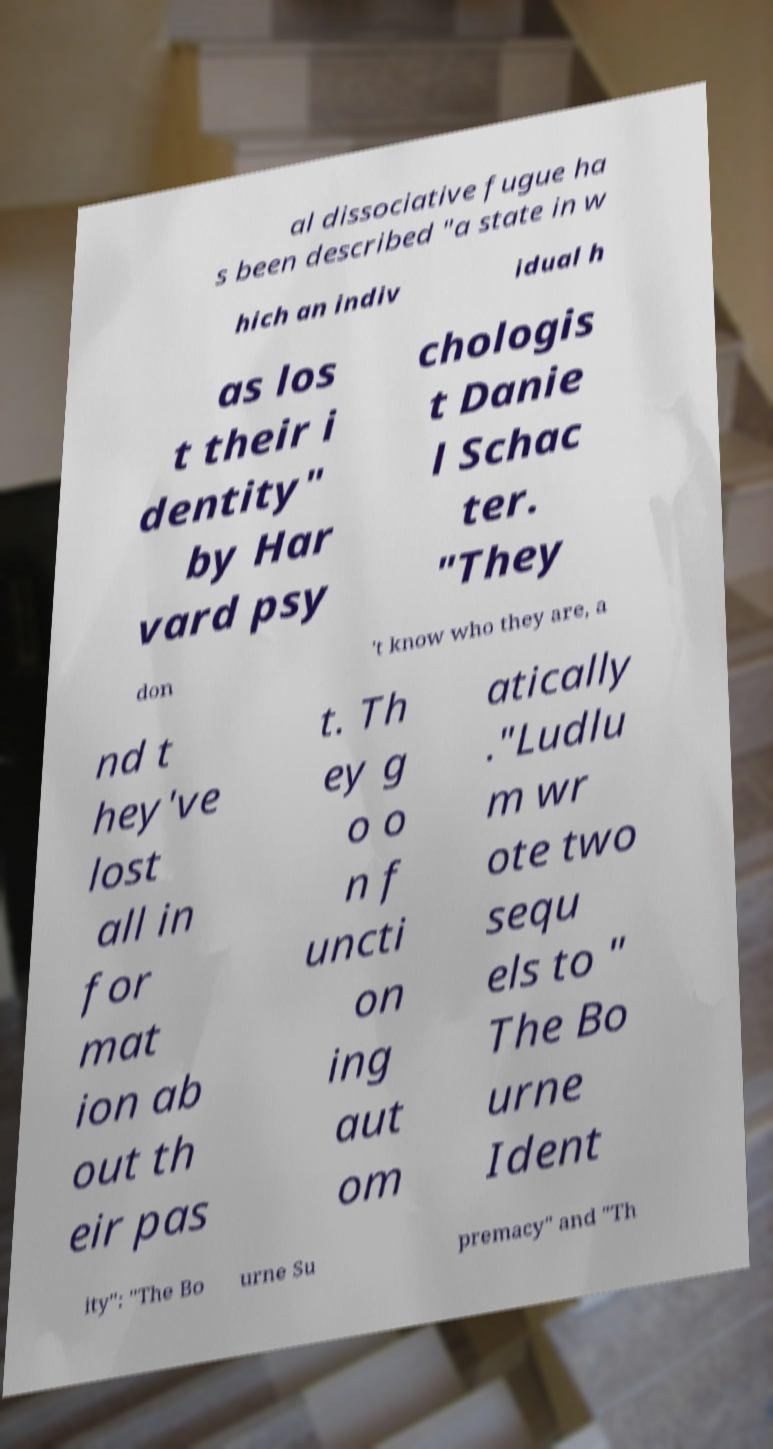Can you accurately transcribe the text from the provided image for me? al dissociative fugue ha s been described "a state in w hich an indiv idual h as los t their i dentity" by Har vard psy chologis t Danie l Schac ter. "They don 't know who they are, a nd t hey've lost all in for mat ion ab out th eir pas t. Th ey g o o n f uncti on ing aut om atically ."Ludlu m wr ote two sequ els to " The Bo urne Ident ity": "The Bo urne Su premacy" and "Th 